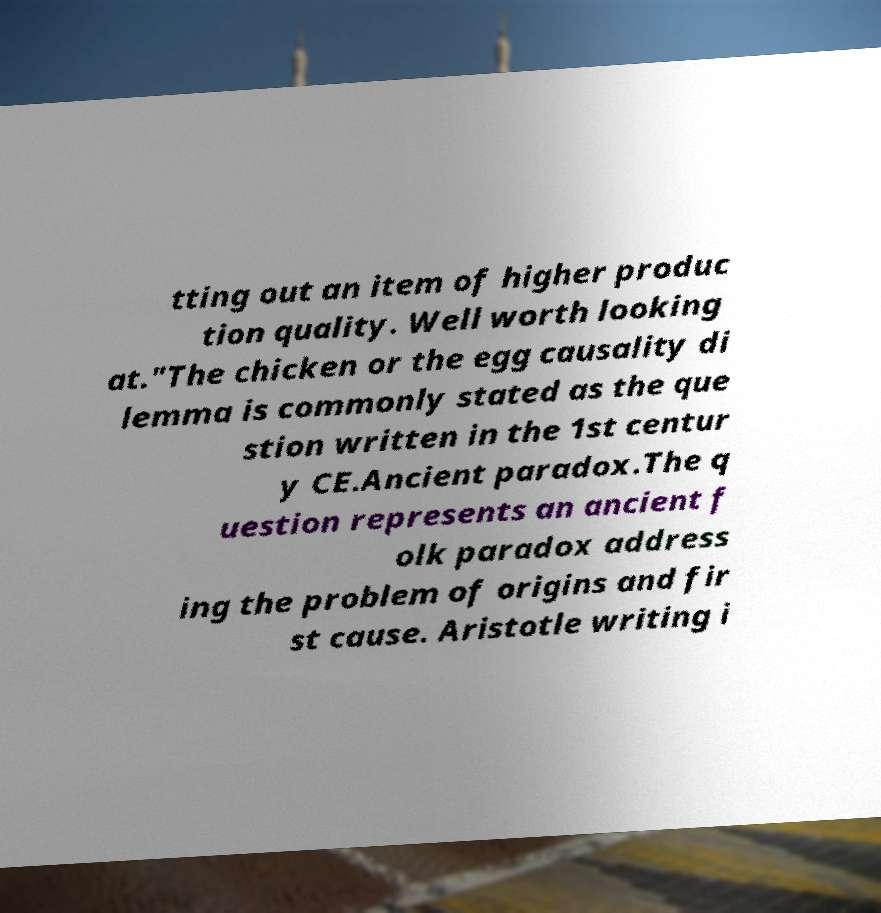For documentation purposes, I need the text within this image transcribed. Could you provide that? tting out an item of higher produc tion quality. Well worth looking at."The chicken or the egg causality di lemma is commonly stated as the que stion written in the 1st centur y CE.Ancient paradox.The q uestion represents an ancient f olk paradox address ing the problem of origins and fir st cause. Aristotle writing i 